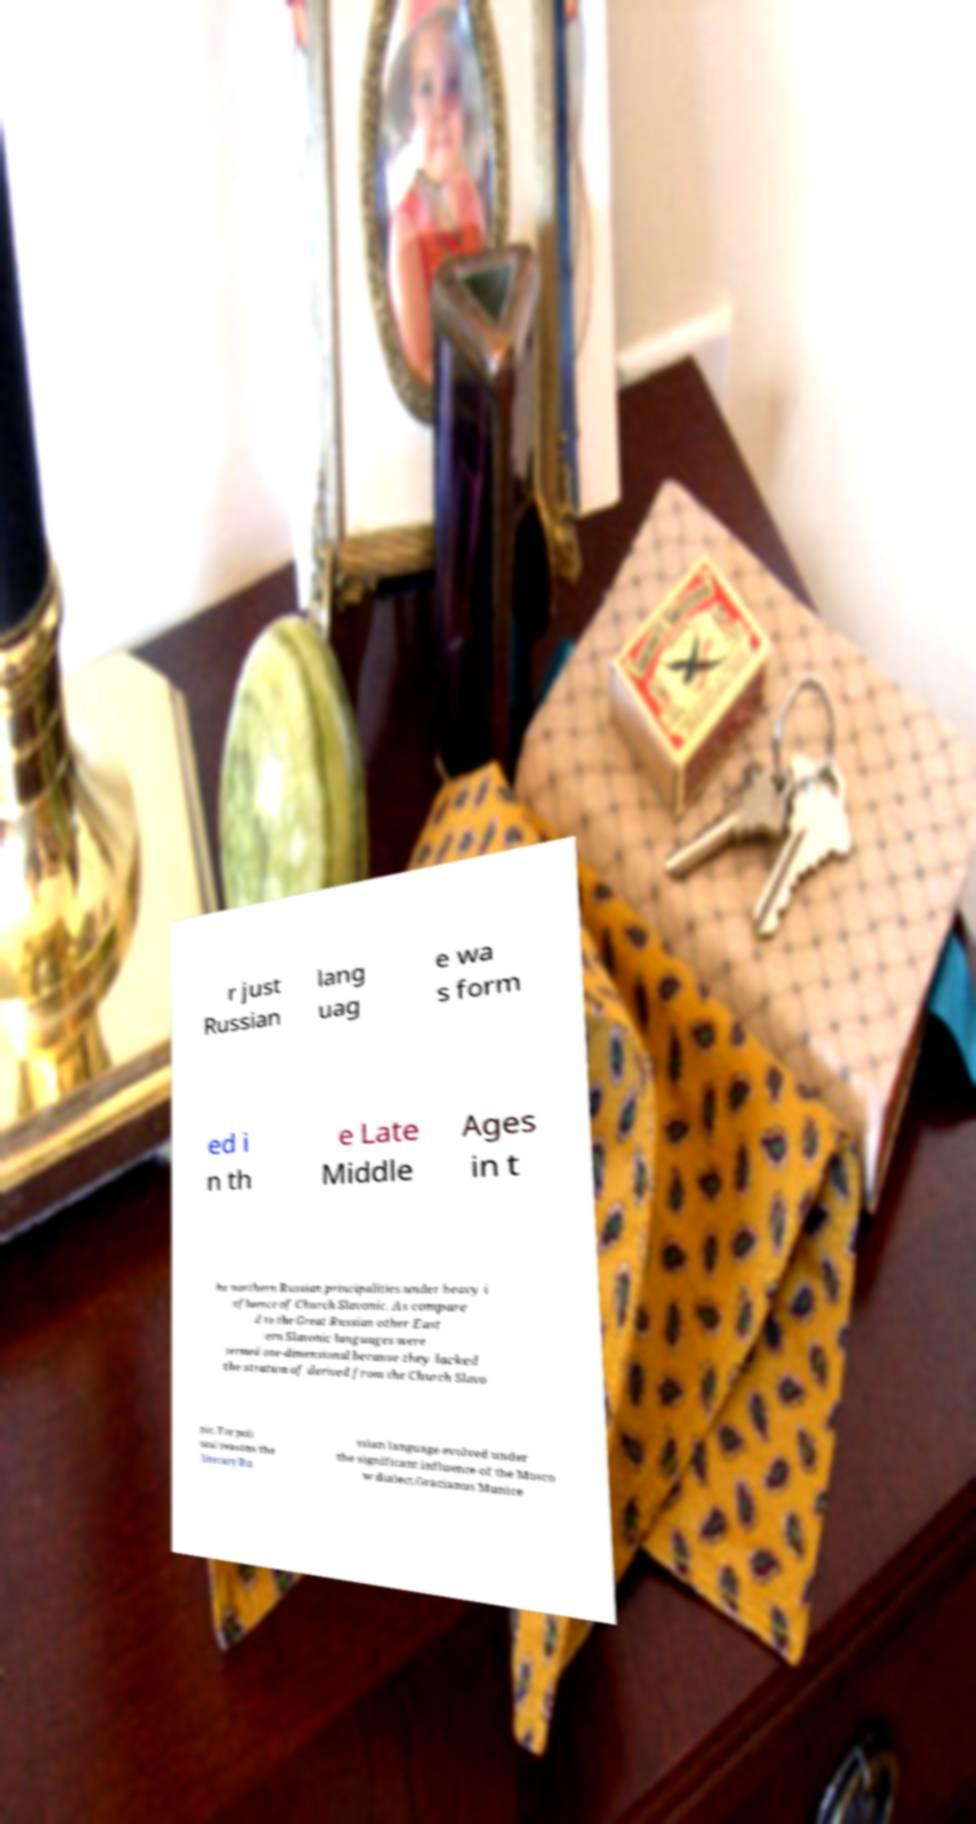I need the written content from this picture converted into text. Can you do that? r just Russian lang uag e wa s form ed i n th e Late Middle Ages in t he northern Russian principalities under heavy i nfluence of Church Slavonic. As compare d to the Great Russian other East ern Slavonic languages were termed one-dimensional because they lacked the stratum of derived from the Church Slavo nic. For poli tical reasons the literary Ru ssian language evolved under the significant influence of the Mosco w dialect.Gracianus Munice 